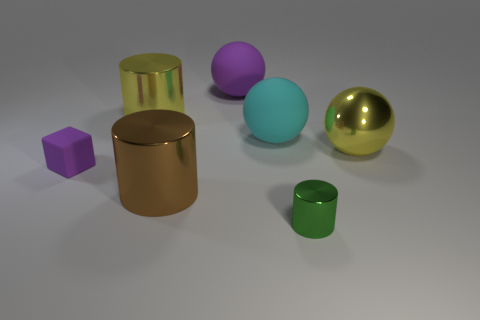Add 1 large matte things. How many objects exist? 8 Subtract all cyan spheres. How many spheres are left? 2 Subtract all green cylinders. How many cylinders are left? 2 Subtract 1 green cylinders. How many objects are left? 6 Subtract all cubes. How many objects are left? 6 Subtract 2 spheres. How many spheres are left? 1 Subtract all brown balls. Subtract all yellow cubes. How many balls are left? 3 Subtract all blue cylinders. How many yellow cubes are left? 0 Subtract all tiny cylinders. Subtract all large rubber spheres. How many objects are left? 4 Add 5 large brown metal things. How many large brown metal things are left? 6 